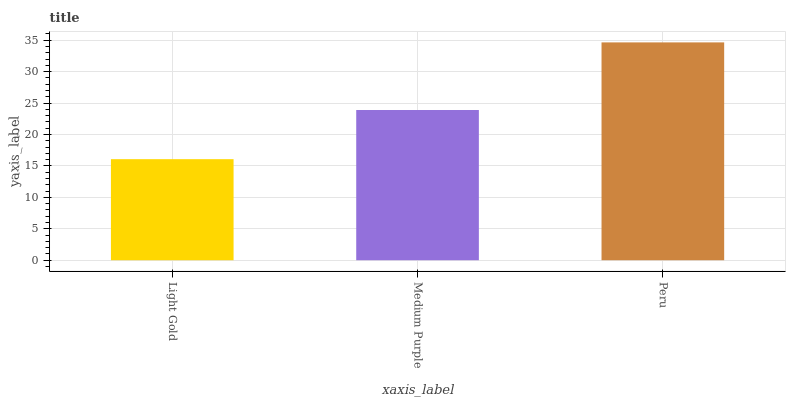Is Light Gold the minimum?
Answer yes or no. Yes. Is Peru the maximum?
Answer yes or no. Yes. Is Medium Purple the minimum?
Answer yes or no. No. Is Medium Purple the maximum?
Answer yes or no. No. Is Medium Purple greater than Light Gold?
Answer yes or no. Yes. Is Light Gold less than Medium Purple?
Answer yes or no. Yes. Is Light Gold greater than Medium Purple?
Answer yes or no. No. Is Medium Purple less than Light Gold?
Answer yes or no. No. Is Medium Purple the high median?
Answer yes or no. Yes. Is Medium Purple the low median?
Answer yes or no. Yes. Is Peru the high median?
Answer yes or no. No. Is Peru the low median?
Answer yes or no. No. 